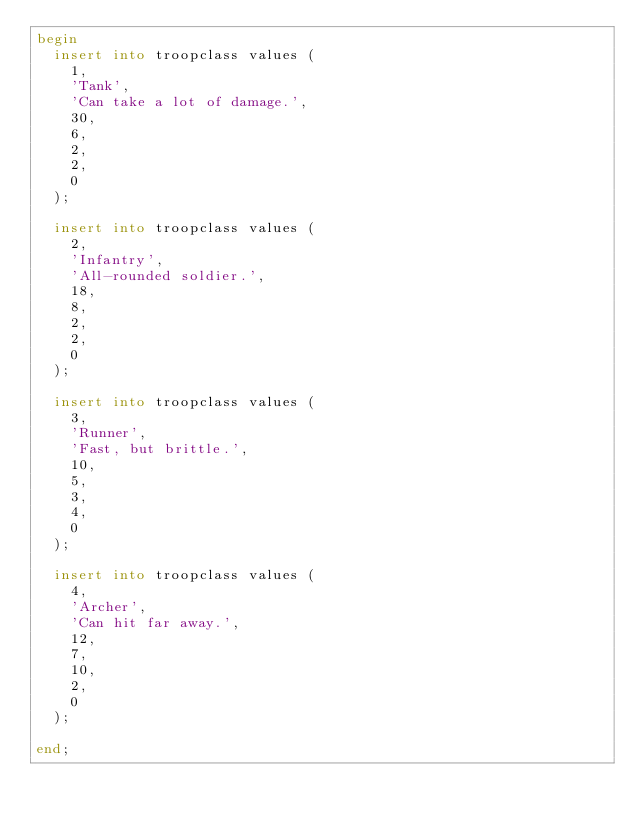Convert code to text. <code><loc_0><loc_0><loc_500><loc_500><_SQL_>begin
  insert into troopclass values (
    1,
    'Tank',
    'Can take a lot of damage.',
    30,
    6,
    2,
    2,
    0
  );
  
  insert into troopclass values (
    2,
    'Infantry',
    'All-rounded soldier.',
    18,
    8,
    2,
    2,
    0
  );
  
  insert into troopclass values (
    3,
    'Runner',
    'Fast, but brittle.',
    10,
    5,
    3,
    4,
    0
  );
  
  insert into troopclass values (
    4,
    'Archer',
    'Can hit far away.',
    12,
    7,
    10,
    2,
    0
  );

end;</code> 